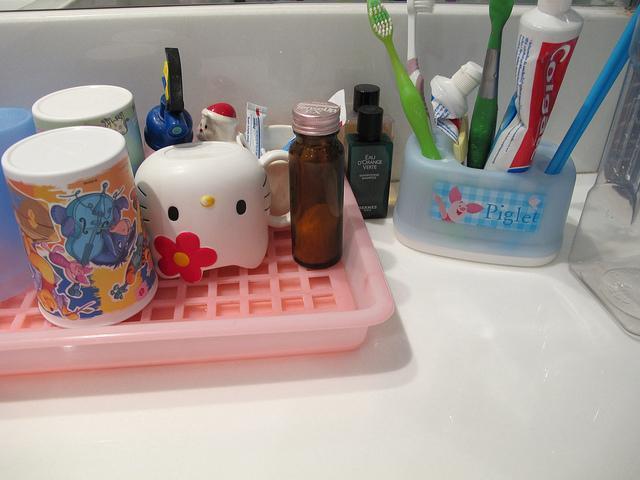How many cups are visible?
Give a very brief answer. 4. How many toothbrushes are there?
Give a very brief answer. 3. How many bottles can be seen?
Give a very brief answer. 3. 